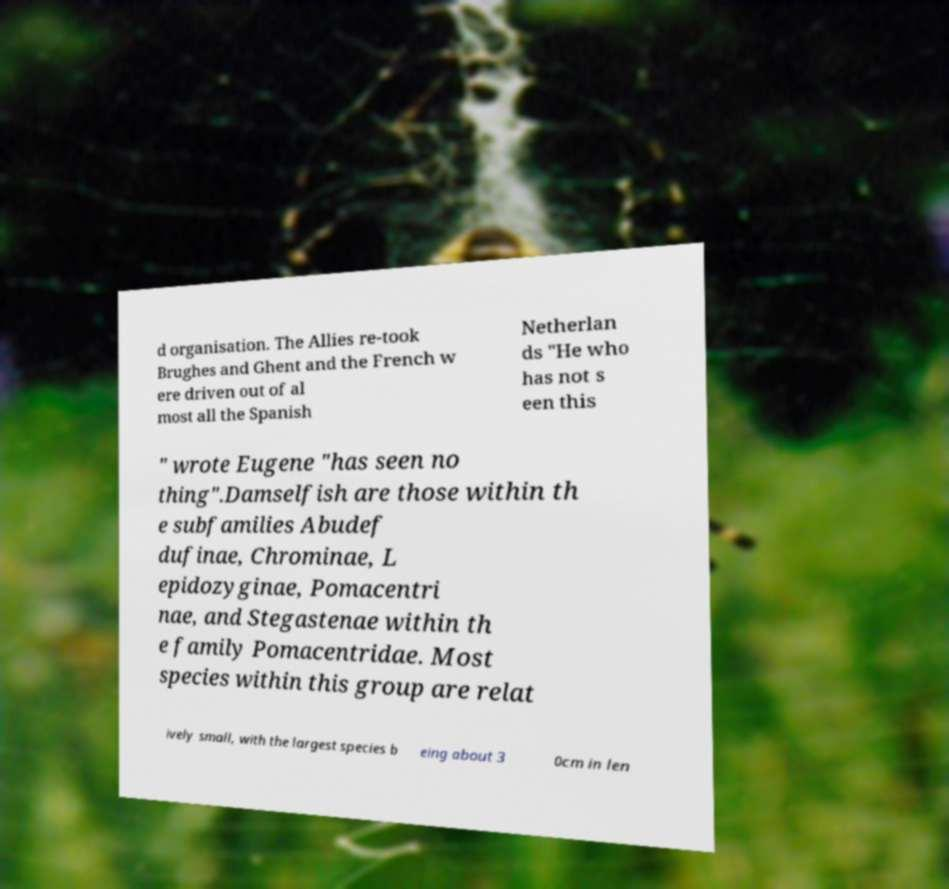I need the written content from this picture converted into text. Can you do that? d organisation. The Allies re-took Brughes and Ghent and the French w ere driven out of al most all the Spanish Netherlan ds "He who has not s een this " wrote Eugene "has seen no thing".Damselfish are those within th e subfamilies Abudef dufinae, Chrominae, L epidozyginae, Pomacentri nae, and Stegastenae within th e family Pomacentridae. Most species within this group are relat ively small, with the largest species b eing about 3 0cm in len 